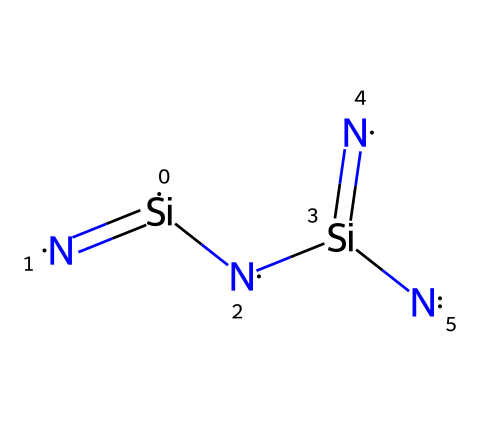How many silicon atoms are in this chemical structure? By examining the SMILES representation, we can identify two silicon atoms present in the structure. Each terminal '[Si]' indicates a silicon atom.
Answer: 2 What type of bonds are indicated between silicon and nitrogen in the structure? The '=' sign in '[Si](=[N])' indicates a double bond between silicon and nitrogen atoms. This is seen in multiple parts of the structure.
Answer: double bond What is the total number of nitrogen atoms present? The SMILES representation shows three nitrogen atoms ('[N]'), so we count the instances of '[N]' in the structure, leading to a total of three nitrogen atoms.
Answer: 3 What is the primary use of silicon nitride in high-performance ceramics? Silicon nitride is primarily known for its high strength and thermal stability, making it ideal for high-performance applications like bearings.
Answer: bearings How does silicon nitride contribute to wear resistance in bearings? Silicon nitride has a dense structure and excellent hardness, which helps minimize wear during frictional contact in bearings.
Answer: wear resistance Which property of silicon nitride contributes to its use in high-temperature applications? The high thermal stability of silicon nitride allows it to maintain its structural integrity at elevated temperatures, which is advantageous for high-temperature applications.
Answer: thermal stability What does the arrangement of silicon and nitrogen suggest about the overall stability of the compound? The alternating bond arrangement creates a strong covalent network, suggesting a high level of structural stability for the compound.
Answer: structural stability 